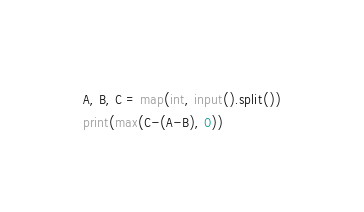Convert code to text. <code><loc_0><loc_0><loc_500><loc_500><_Python_>A, B, C = map(int, input().split())
print(max(C-(A-B), 0))
</code> 